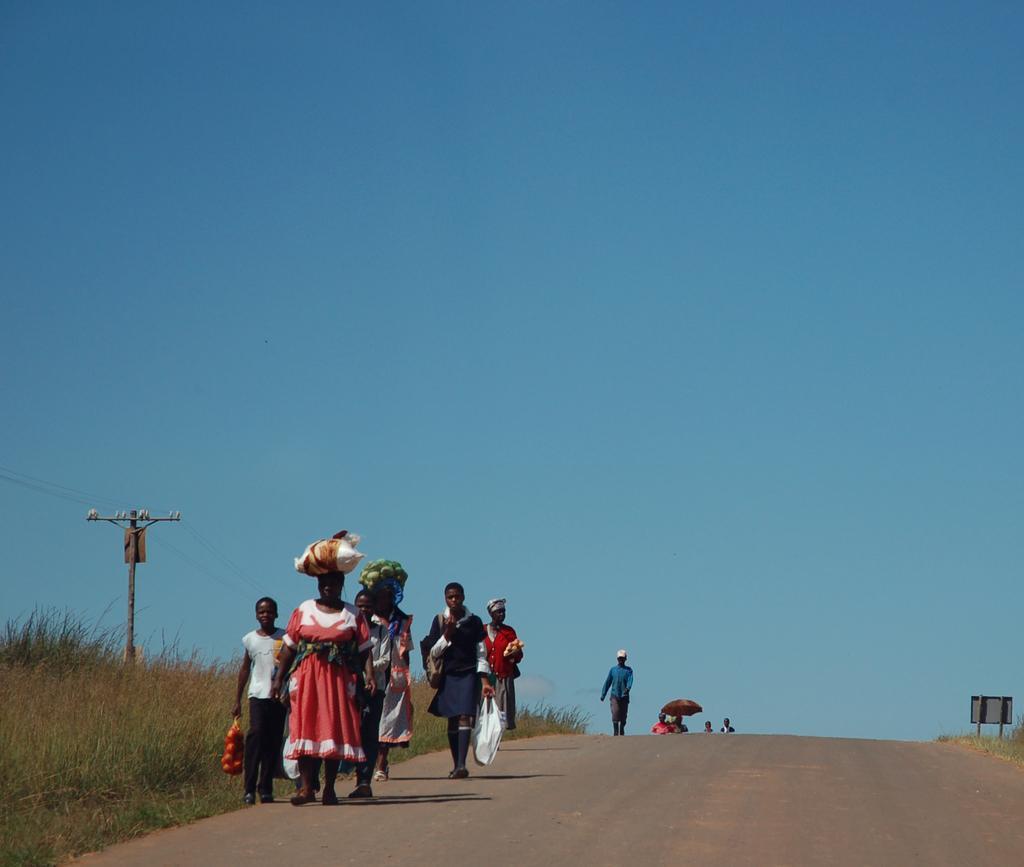In one or two sentences, can you explain what this image depicts? In this picture there are few persons standing and holding few objects in their hands and there is green grass beside them and there are few other persons in the background and the sky is in blue color. 